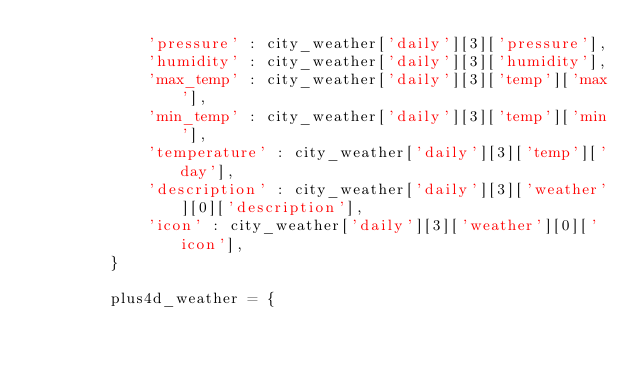Convert code to text. <code><loc_0><loc_0><loc_500><loc_500><_Python_>            'pressure' : city_weather['daily'][3]['pressure'],
            'humidity' : city_weather['daily'][3]['humidity'],
            'max_temp' : city_weather['daily'][3]['temp']['max'],
            'min_temp' : city_weather['daily'][3]['temp']['min'],
            'temperature' : city_weather['daily'][3]['temp']['day'],
            'description' : city_weather['daily'][3]['weather'][0]['description'],
            'icon' : city_weather['daily'][3]['weather'][0]['icon'],
        }

        plus4d_weather = {</code> 